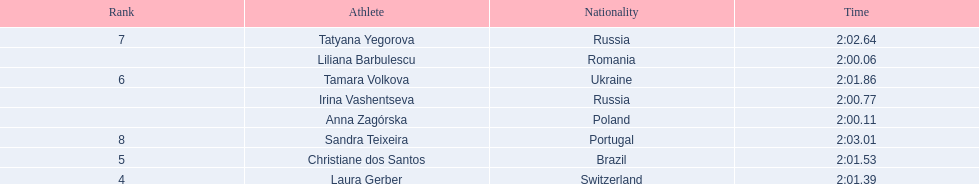What is the name of the top finalist of this semifinals heat? Liliana Barbulescu. 